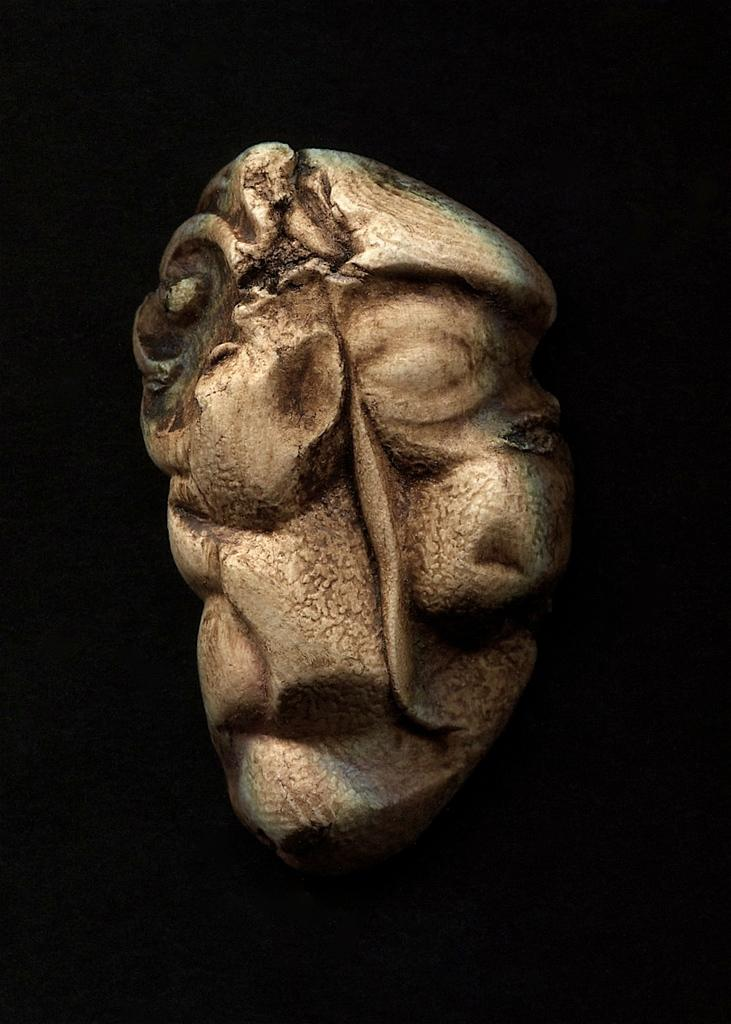What is the main subject of the image? The main subject of the image is a stone. What can be said about the color of the stone? The stone is gold in color. Has the stone been modified in any way? Yes, the stone is carved into a shape. What is the color of the background in the image? The background of the image is dark. What is the shocking theory proposed by the stone in the image? There is no theory proposed by the stone in the image, as it is an inanimate object. 